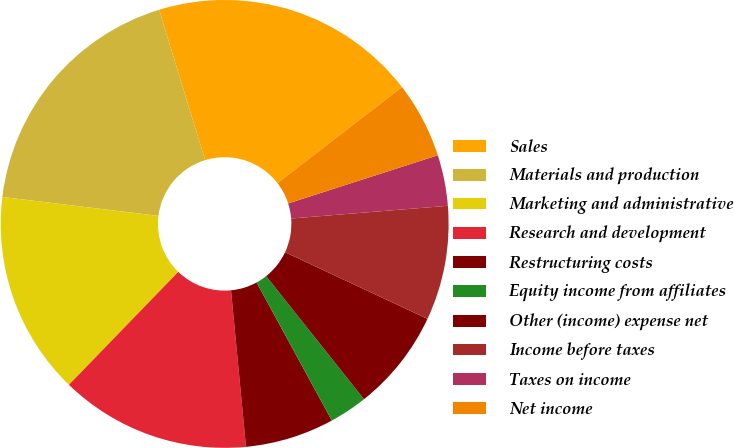Convert chart. <chart><loc_0><loc_0><loc_500><loc_500><pie_chart><fcel>Sales<fcel>Materials and production<fcel>Marketing and administrative<fcel>Research and development<fcel>Restructuring costs<fcel>Equity income from affiliates<fcel>Other (income) expense net<fcel>Income before taxes<fcel>Taxes on income<fcel>Net income<nl><fcel>19.27%<fcel>18.35%<fcel>14.68%<fcel>13.76%<fcel>6.42%<fcel>2.75%<fcel>7.34%<fcel>8.26%<fcel>3.67%<fcel>5.5%<nl></chart> 